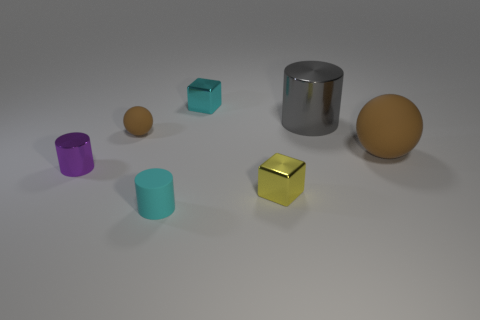Can you describe the colors and materials of the objects in the image? Certainly! In this image, we have objects with varied colors and materials. Starting from the left, there's a purple matte cylinder, a small orange sphere with a matte finish, and a cyan transparent cube. The large cylinder in the center has a metallic sheen and is reflective, while the smaller yellow cube to the right has a glossy, somewhat reflective surface. On the far right, there is a larger orange sphere that shares the same matte finish as the small one. 